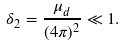<formula> <loc_0><loc_0><loc_500><loc_500>\delta _ { 2 } = \frac { \mu _ { d } } { ( 4 \pi ) ^ { 2 } } \ll 1 .</formula> 